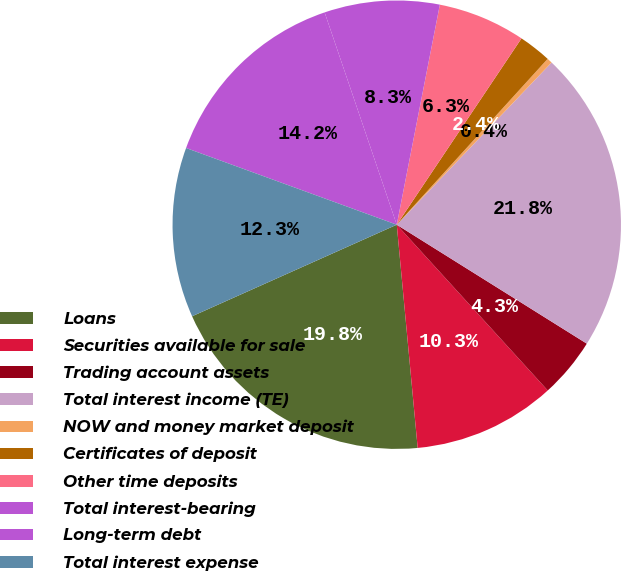<chart> <loc_0><loc_0><loc_500><loc_500><pie_chart><fcel>Loans<fcel>Securities available for sale<fcel>Trading account assets<fcel>Total interest income (TE)<fcel>NOW and money market deposit<fcel>Certificates of deposit<fcel>Other time deposits<fcel>Total interest-bearing<fcel>Long-term debt<fcel>Total interest expense<nl><fcel>19.79%<fcel>10.27%<fcel>4.34%<fcel>21.77%<fcel>0.38%<fcel>2.36%<fcel>6.31%<fcel>8.29%<fcel>14.23%<fcel>12.25%<nl></chart> 